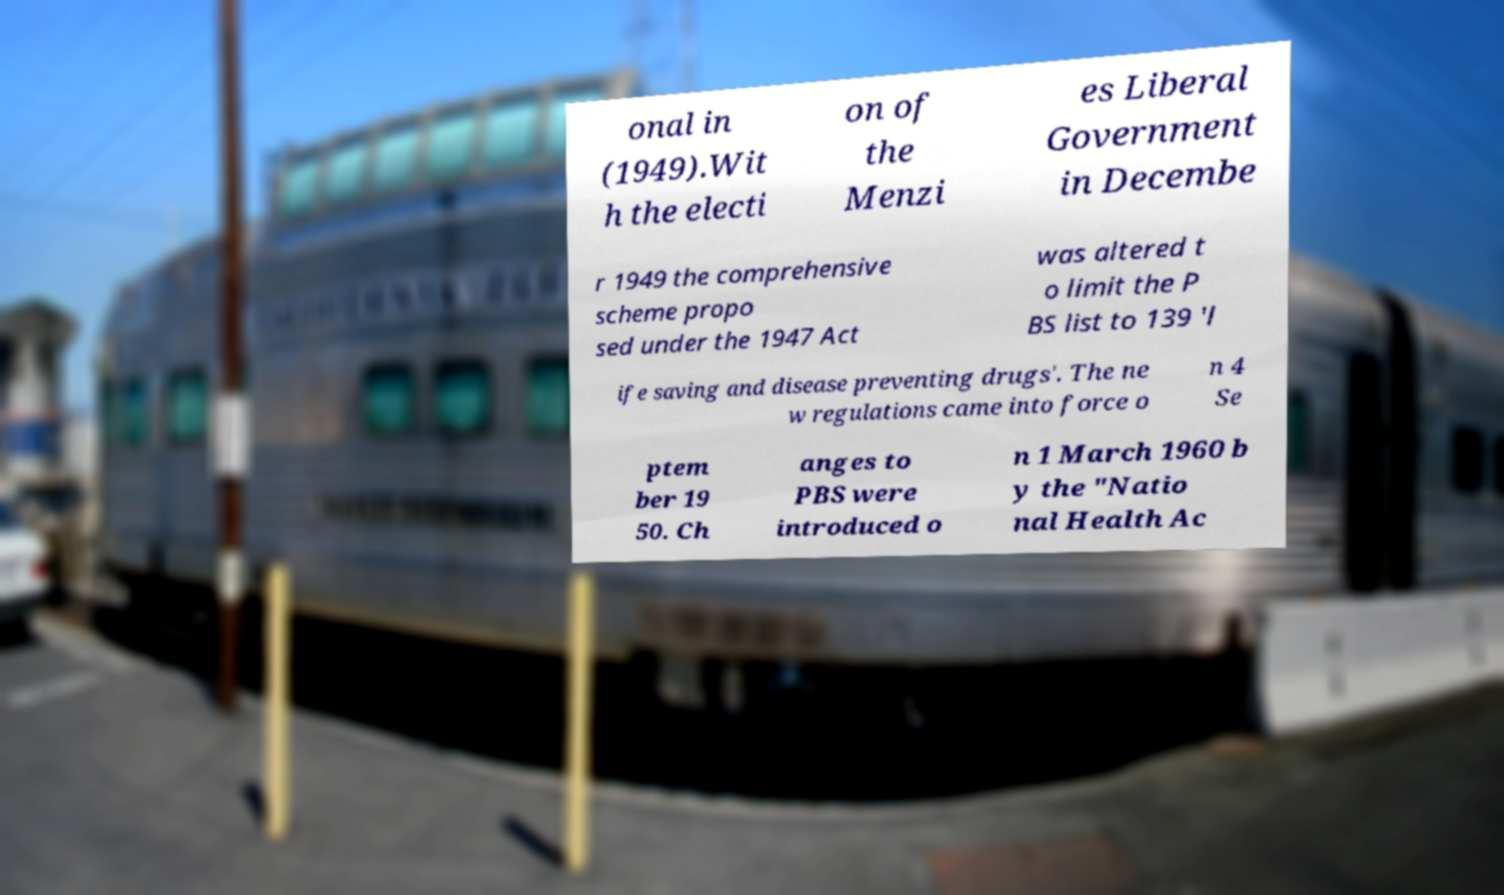Please identify and transcribe the text found in this image. onal in (1949).Wit h the electi on of the Menzi es Liberal Government in Decembe r 1949 the comprehensive scheme propo sed under the 1947 Act was altered t o limit the P BS list to 139 'l ife saving and disease preventing drugs'. The ne w regulations came into force o n 4 Se ptem ber 19 50. Ch anges to PBS were introduced o n 1 March 1960 b y the "Natio nal Health Ac 